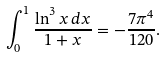Convert formula to latex. <formula><loc_0><loc_0><loc_500><loc_500>\int _ { 0 } ^ { 1 } \frac { \ln ^ { 3 } x \, d x } { 1 + x } = - \frac { 7 \pi ^ { 4 } } { 1 2 0 } .</formula> 